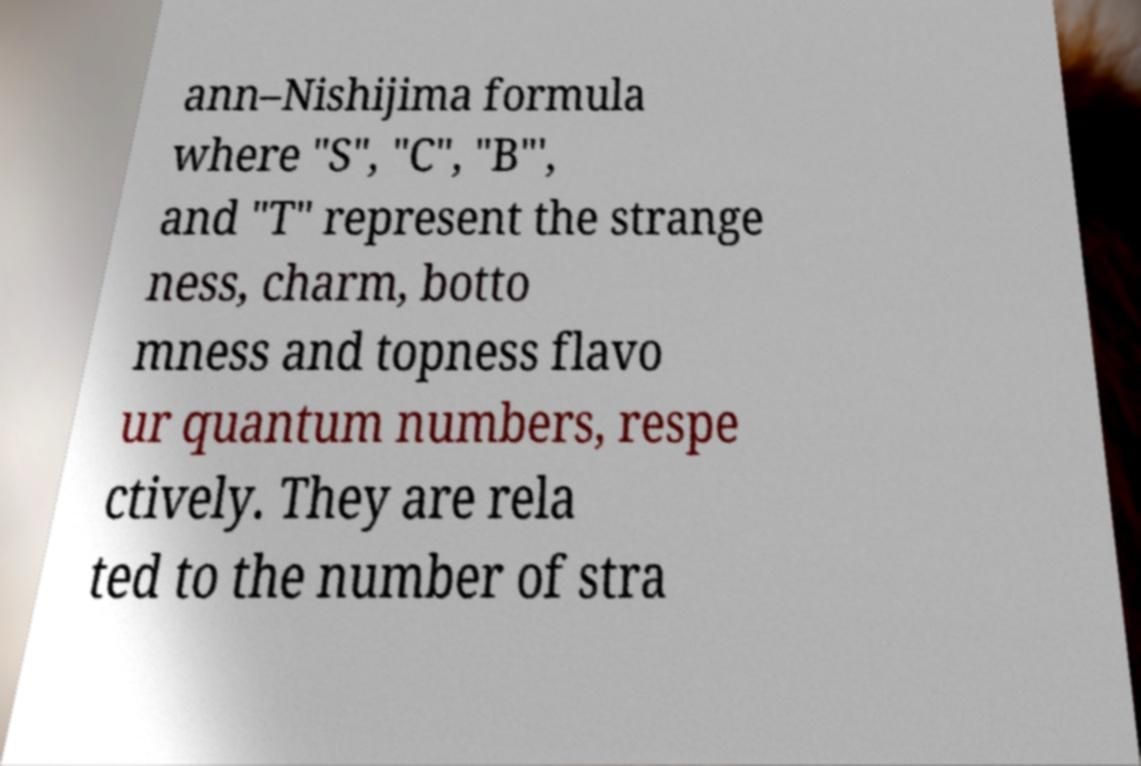Could you extract and type out the text from this image? ann–Nishijima formula where "S", "C", "B"′, and "T" represent the strange ness, charm, botto mness and topness flavo ur quantum numbers, respe ctively. They are rela ted to the number of stra 